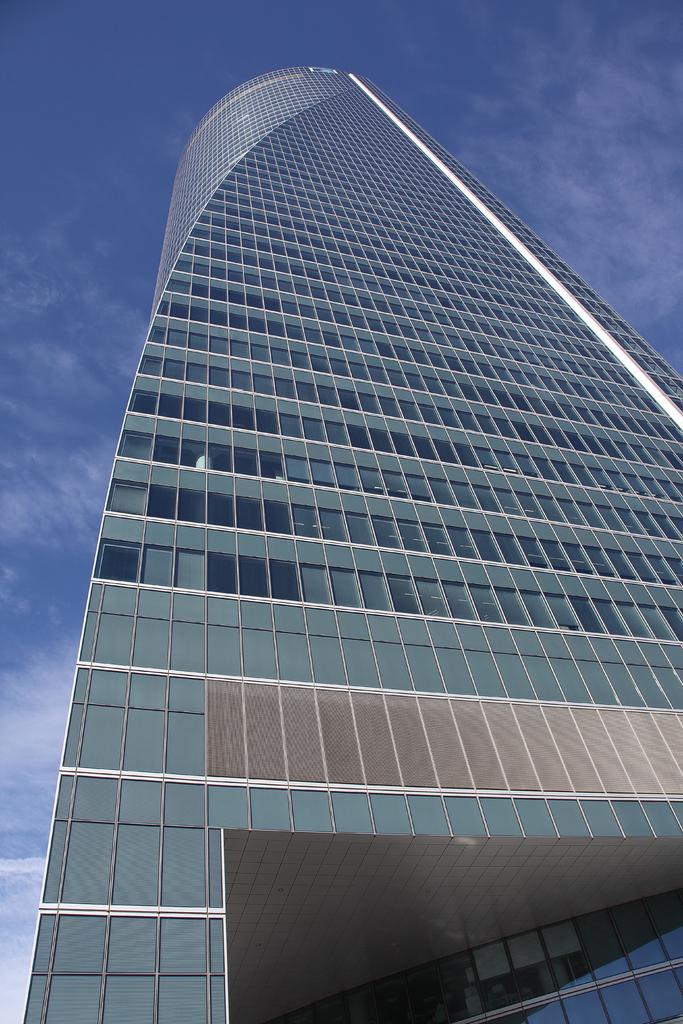What type of structure is present in the image? There is a building in the image. What can be seen in the sky in the image? There are clouds visible in the sky in the image. What color is the toy in the image? There is no toy present in the image. How far away is the building from the clouds in the image? The distance between the building and the clouds cannot be determined from the image, as it is a two-dimensional representation. 